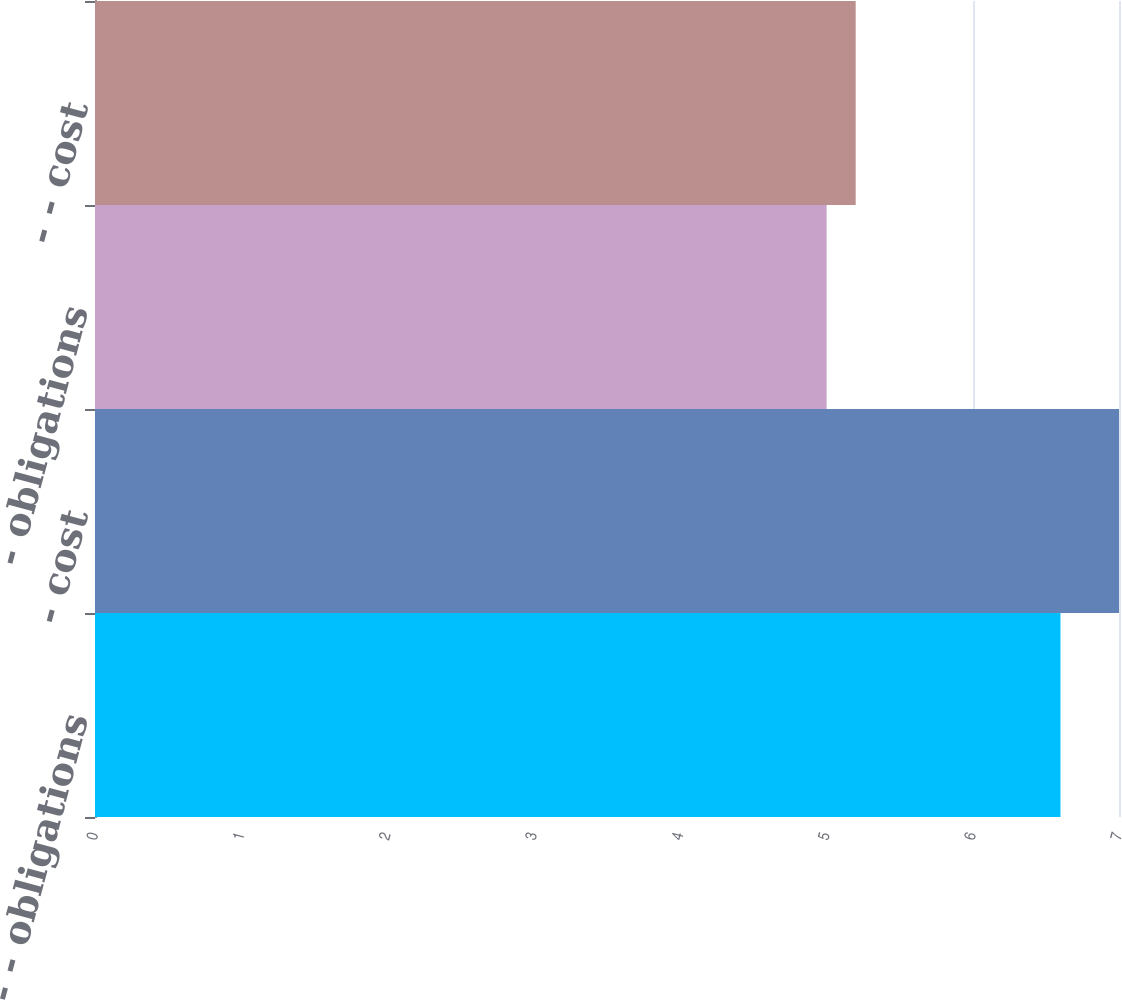Convert chart to OTSL. <chart><loc_0><loc_0><loc_500><loc_500><bar_chart><fcel>- - obligations<fcel>- cost<fcel>- obligations<fcel>- - cost<nl><fcel>6.6<fcel>7<fcel>5<fcel>5.2<nl></chart> 